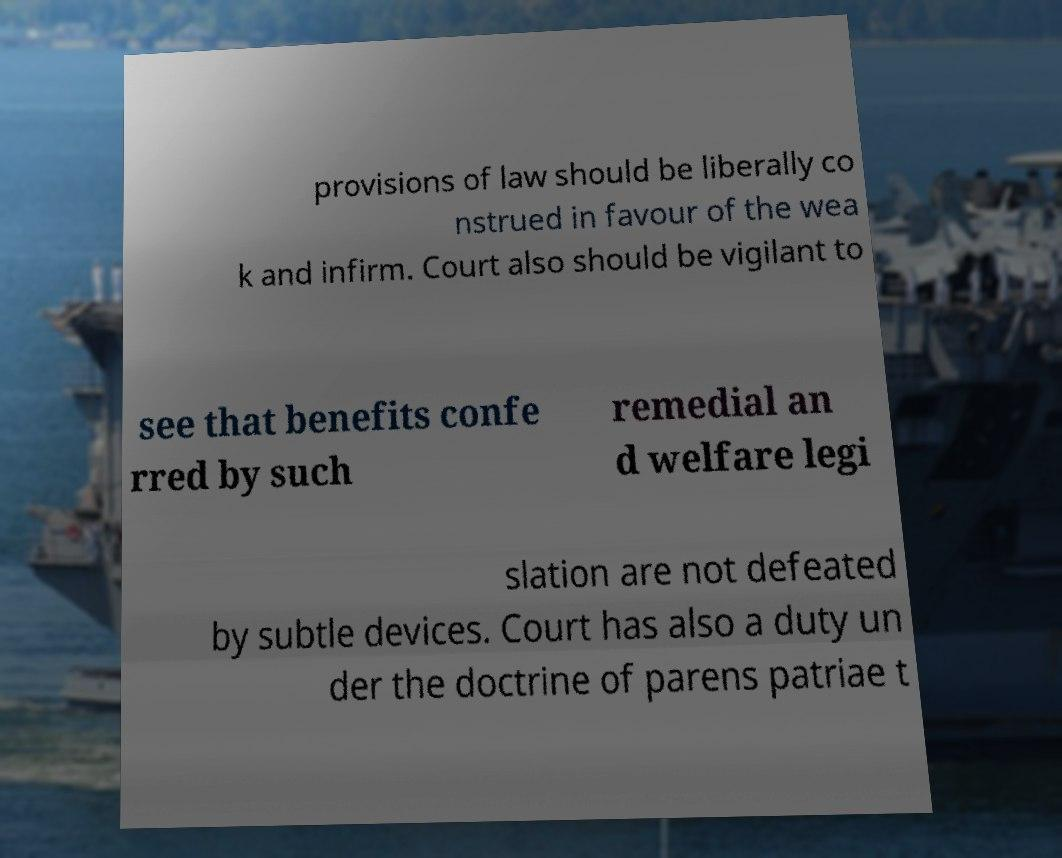Could you assist in decoding the text presented in this image and type it out clearly? provisions of law should be liberally co nstrued in favour of the wea k and infirm. Court also should be vigilant to see that benefits confe rred by such remedial an d welfare legi slation are not defeated by subtle devices. Court has also a duty un der the doctrine of parens patriae t 